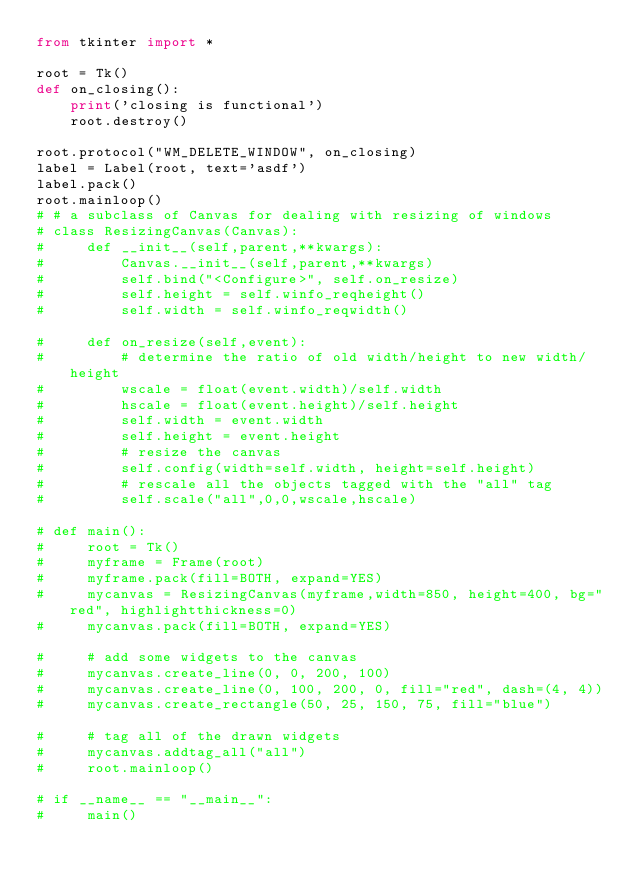<code> <loc_0><loc_0><loc_500><loc_500><_Python_>from tkinter import *

root = Tk()
def on_closing():
    print('closing is functional')
    root.destroy()

root.protocol("WM_DELETE_WINDOW", on_closing)
label = Label(root, text='asdf')
label.pack()
root.mainloop()
# # a subclass of Canvas for dealing with resizing of windows
# class ResizingCanvas(Canvas):
#     def __init__(self,parent,**kwargs):
#         Canvas.__init__(self,parent,**kwargs)
#         self.bind("<Configure>", self.on_resize)
#         self.height = self.winfo_reqheight()
#         self.width = self.winfo_reqwidth()

#     def on_resize(self,event):
#         # determine the ratio of old width/height to new width/height
#         wscale = float(event.width)/self.width
#         hscale = float(event.height)/self.height
#         self.width = event.width
#         self.height = event.height
#         # resize the canvas 
#         self.config(width=self.width, height=self.height)
#         # rescale all the objects tagged with the "all" tag
#         self.scale("all",0,0,wscale,hscale)

# def main():
#     root = Tk()
#     myframe = Frame(root)
#     myframe.pack(fill=BOTH, expand=YES)
#     mycanvas = ResizingCanvas(myframe,width=850, height=400, bg="red", highlightthickness=0)
#     mycanvas.pack(fill=BOTH, expand=YES)

#     # add some widgets to the canvas
#     mycanvas.create_line(0, 0, 200, 100)
#     mycanvas.create_line(0, 100, 200, 0, fill="red", dash=(4, 4))
#     mycanvas.create_rectangle(50, 25, 150, 75, fill="blue")

#     # tag all of the drawn widgets
#     mycanvas.addtag_all("all")
#     root.mainloop()

# if __name__ == "__main__":
#     main()</code> 